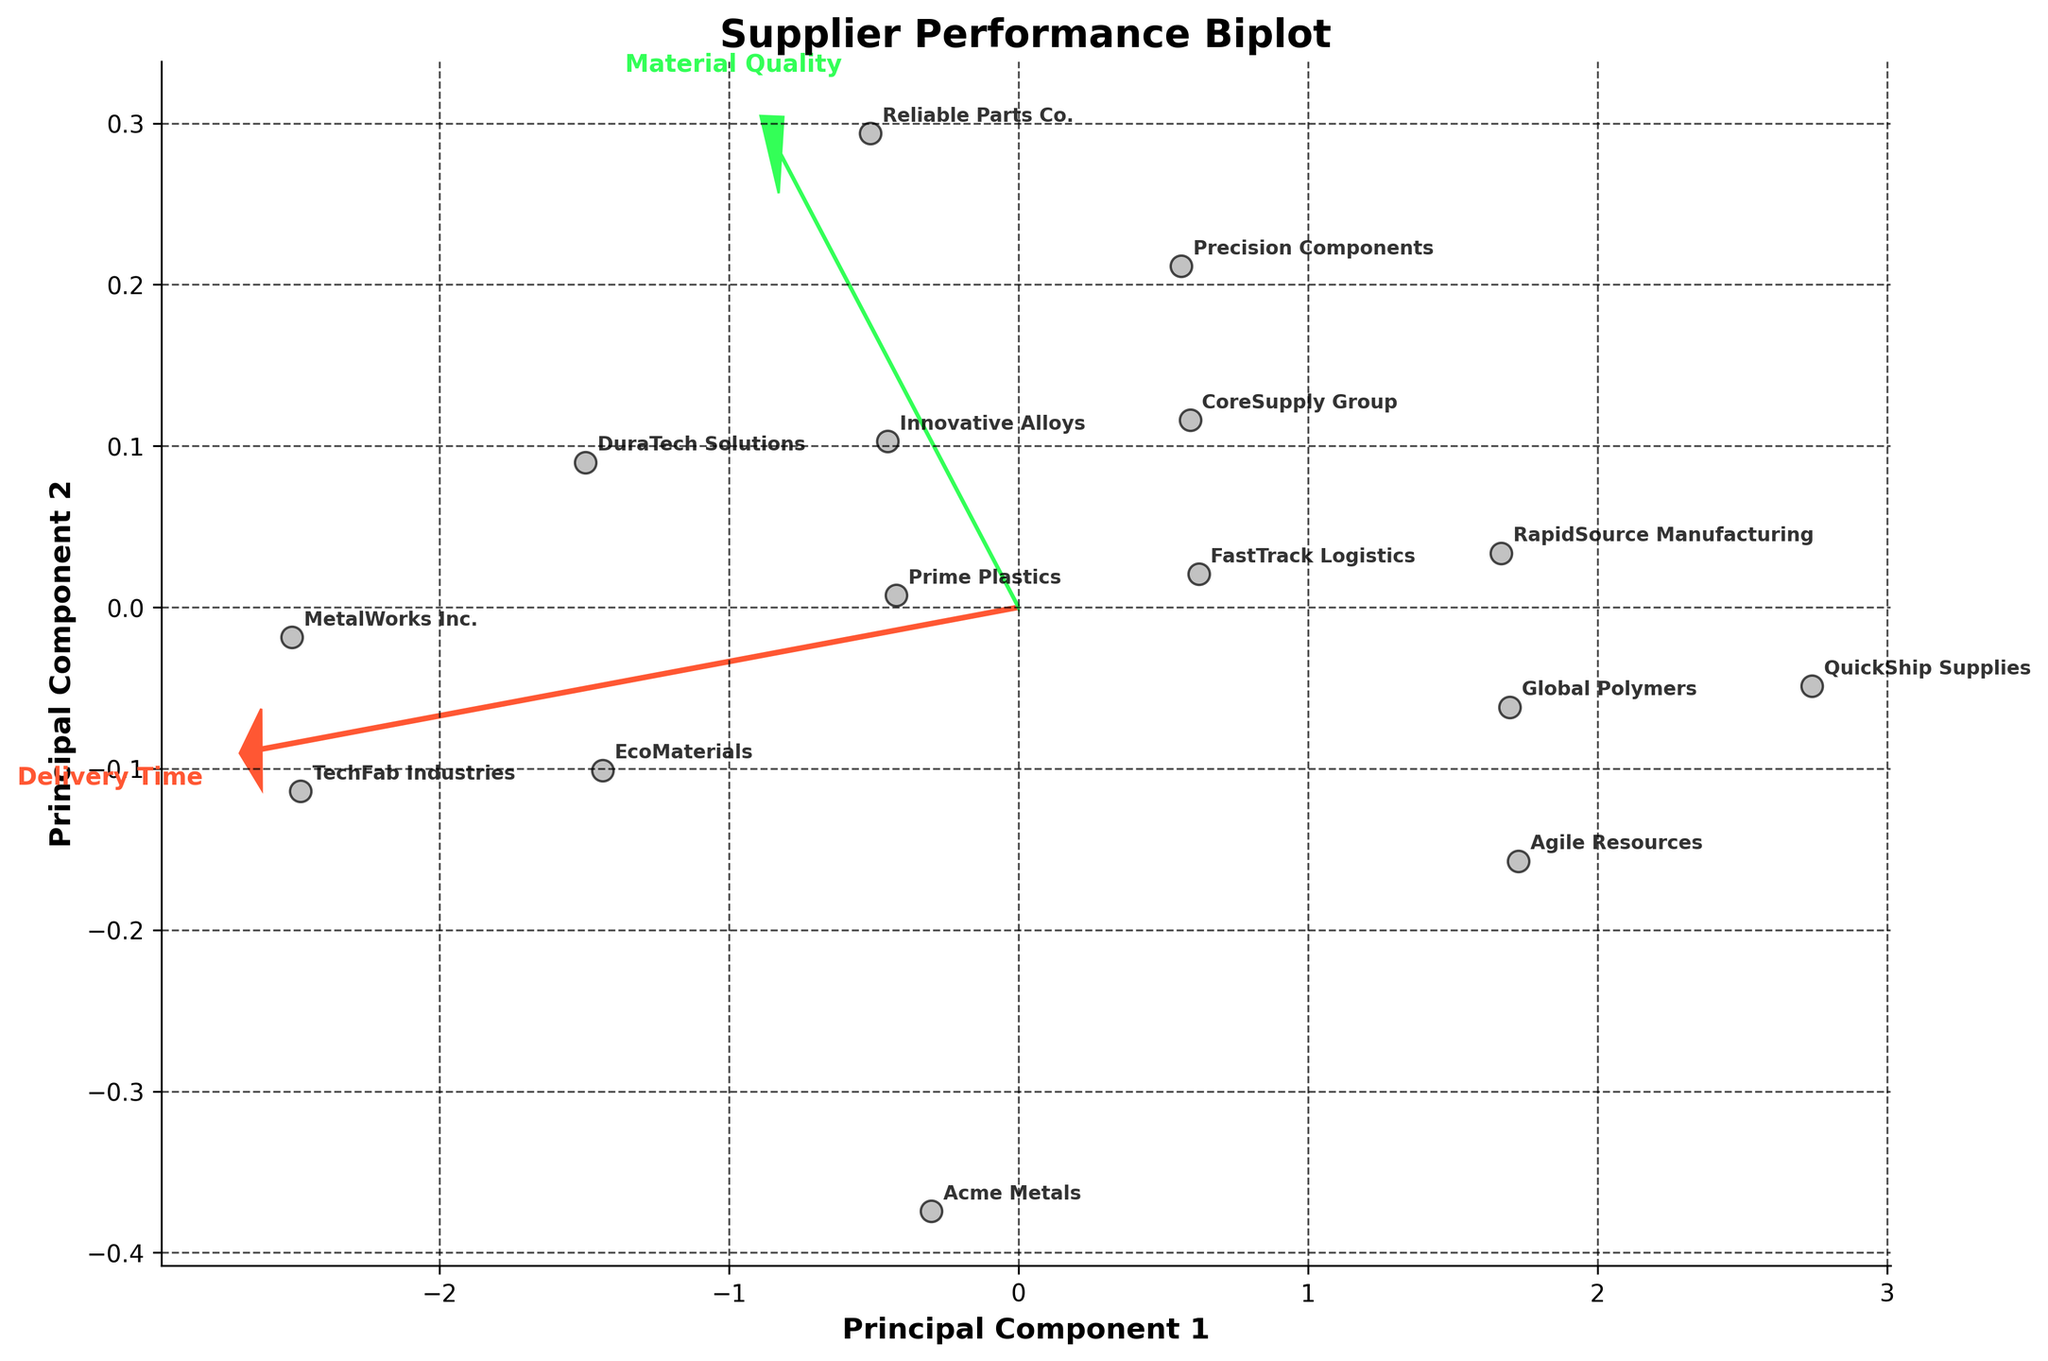What is the title of the biplot? The title can be found at the top of the plot, usually in a larger and bold font. Look for the text that describes the overall purpose of the visualization.
Answer: Supplier Performance Biplot How many suppliers are represented in the biplot? Each data point in the scatter plot represents one supplier. By counting the total number of points, you can determine the number of suppliers.
Answer: 15 Which supplier has the longest delivery time? Identify the point that lies farthest along the direction of the "Delivery Time" arrow. This can be found by observing the projections of the data points in the biplot relative to this vector.
Answer: TechFab Industries Between "EcoMaterials" and "Prime Plastics," which supplier has better material quality? Compare the positions of the data points for "EcoMaterials" and "Prime Plastics" along the "Material Quality" vector. The supplier lying further in the positive direction of this vector has better material quality.
Answer: EcoMaterials Which two suppliers have the closest performance in the biplot? By observing the distances between all pairs of points, identify the two data points that are the nearest to each other in the 2D space.
Answer: Global Polymers and RapidSource Manufacturing What does the direction of the "Delivery Time" arrow indicate? The direction of the arrow or vector for "Delivery Time" represents an increase in the delivery time. Analyze the plot to see the orientation of this vector, generally pointing towards areas with higher delivery times.
Answer: Increase in delivery time Are there any suppliers that show a high-quality score but also a long delivery time? Look for data points that are located in the upper sections of both the "Material Quality" vector and the "Delivery Time" vector. These points will be far in both the directions representing good quality and long delivery time.
Answer: TechFab Industries and MetalWorks Inc How does "QuickShip Supplies" compare to "FastTrack Logistics" in terms of delivery time? Identify the positions of these two suppliers in relation to the "Delivery Time" vector. The supplier closer to the origin in the direction of this vector has a shorter delivery time.
Answer: QuickShip Supplies has a shorter delivery time Which principal component captures the variation in delivery time more effectively? Observe which principal component direction aligns more closely with the "Delivery Time" arrow. The principal component that is more aligned captures more variation in delivery time.
Answer: Principal Component 1 